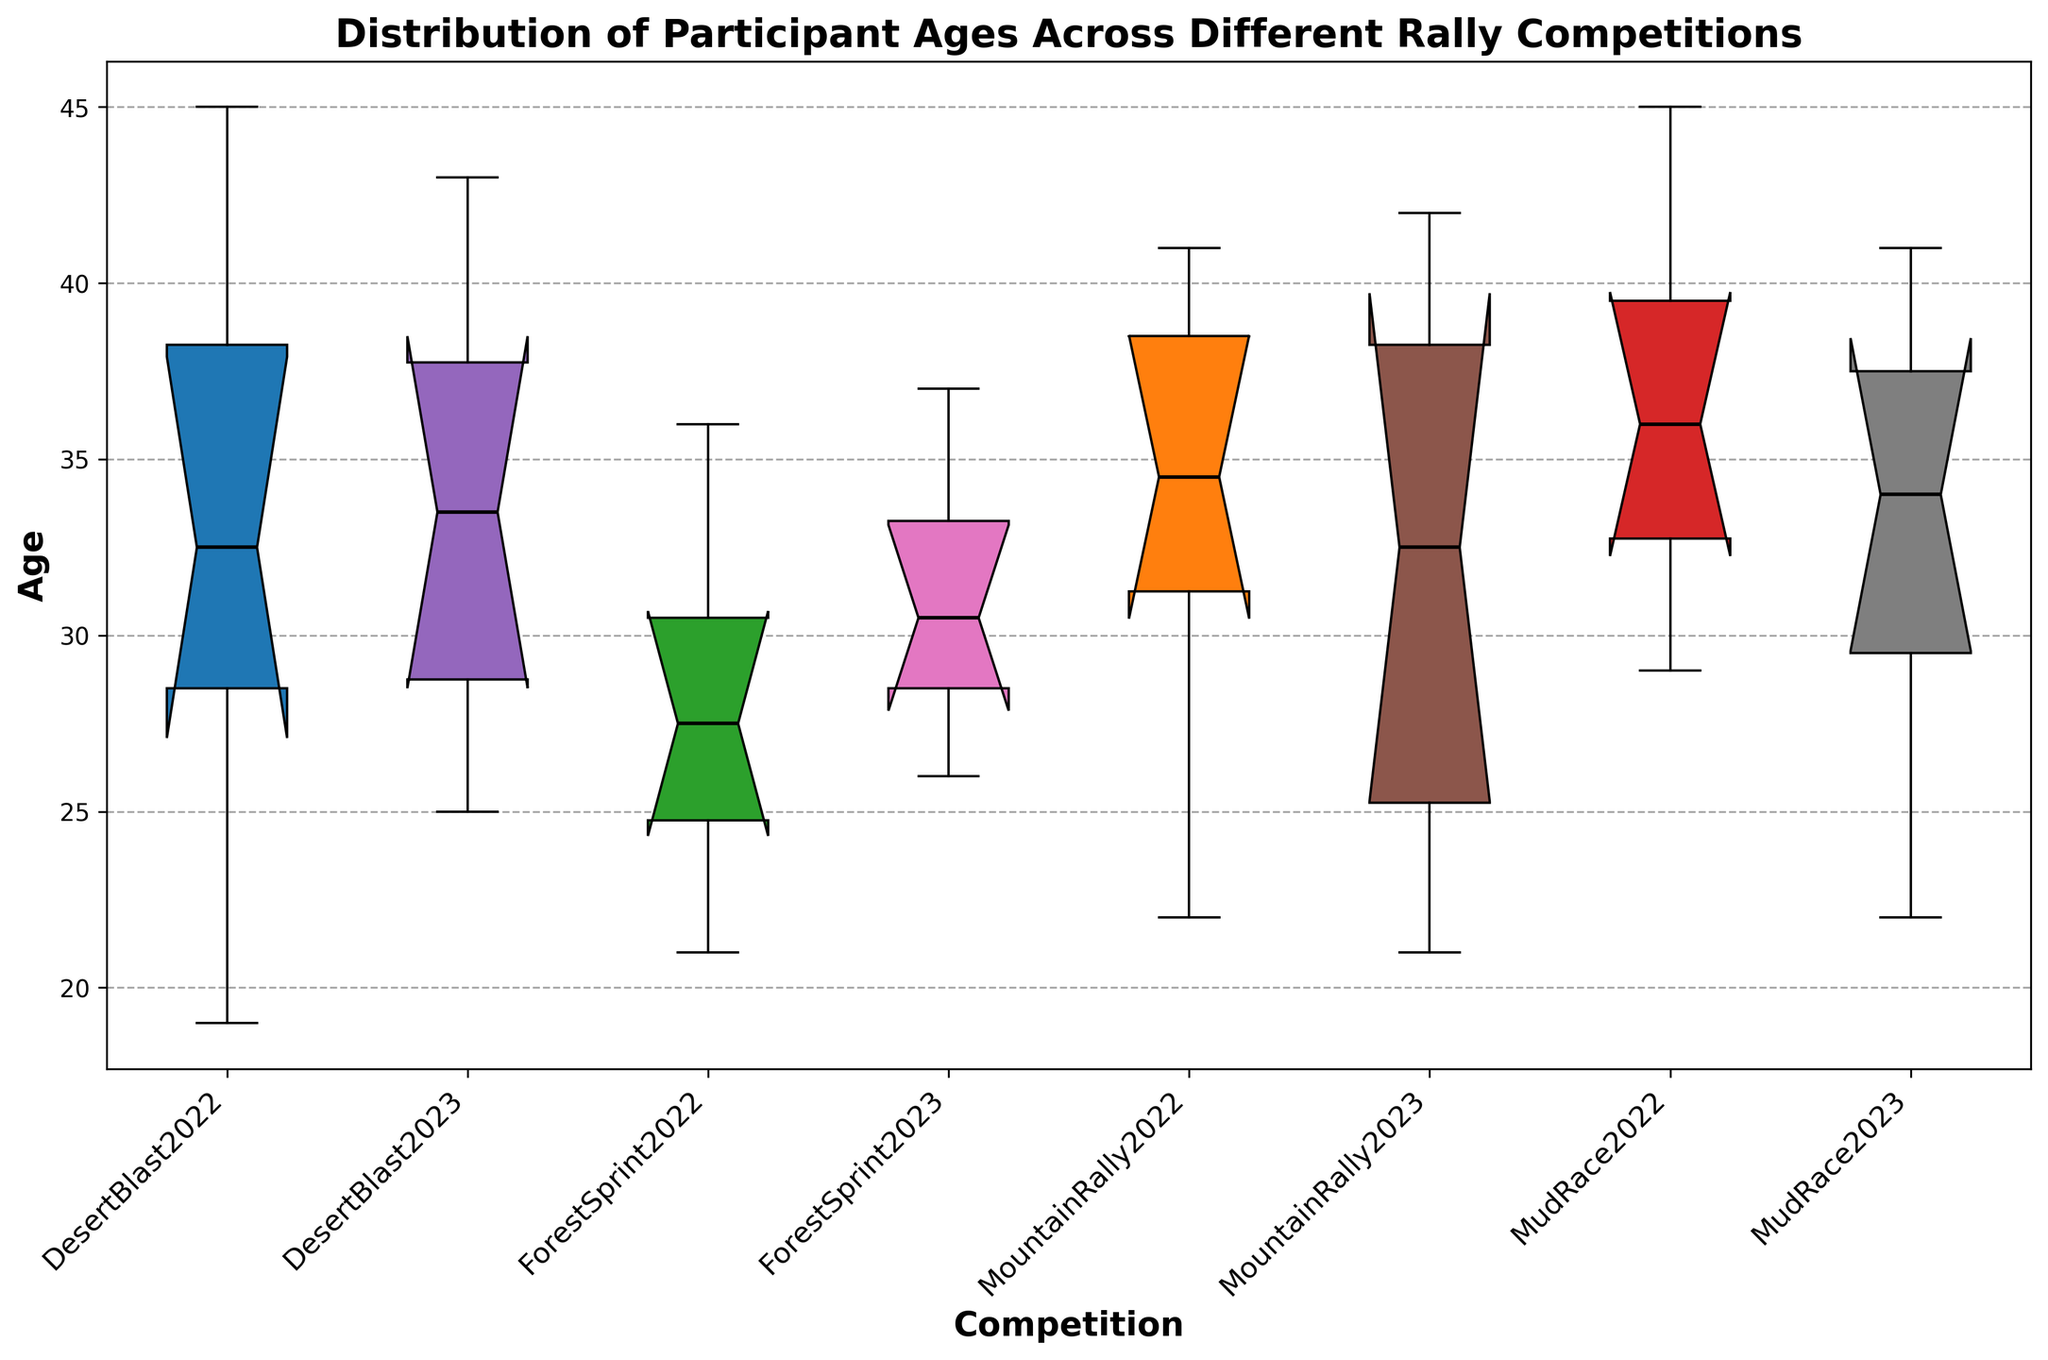What's the median age for DesertBlast2022? Look at the boxplot for DesertBlast2022 and identify the line inside the box that represents the median.
Answer: 31 Which competition has the highest median age? Compare the medians (middle lines) across all the boxplots and identify the one that is the highest.
Answer: MudRace2022 Which competition has the widest age range? Identify the boxplot with the highest difference between the top whisker (maximum) and the bottom whisker (minimum).
Answer: MudRace2022 Is the median age higher in DesertBlast2023 or MountainRally2023? Compare the positions of the medians in the DesertBlast2023 and MountainRally2023 boxplots.
Answer: DesertBlast2023 What is the interquartile range (IQR) for ForestSprint2023? The IQR is the difference between the upper quartile (top of the box) and lower quartile (bottom of the box) in the ForestSprint2023 boxplot.
Answer: 7 Which competition has the smallest IQR? Look at the height of the boxes for each competition and identify which one is the smallest.
Answer: MountainRally2022 How does the distribution of participant ages in DesertBlast2022 compare to MudRace2022 in terms of spread and outliers? Observe the length of the boxes (IQR) and the presence of any points outside the whiskers (outliers) for both DesertBlast2022 and MudRace2022 boxplots.
Answer: MudRace2022 has a larger spread and more outliers Which competitions do not have any outliers? Look for boxplots without any dots outside the whiskers.
Answer: ForestSprint2022, DesertBlast2023, MountainRally2023, ForestSprint2023 